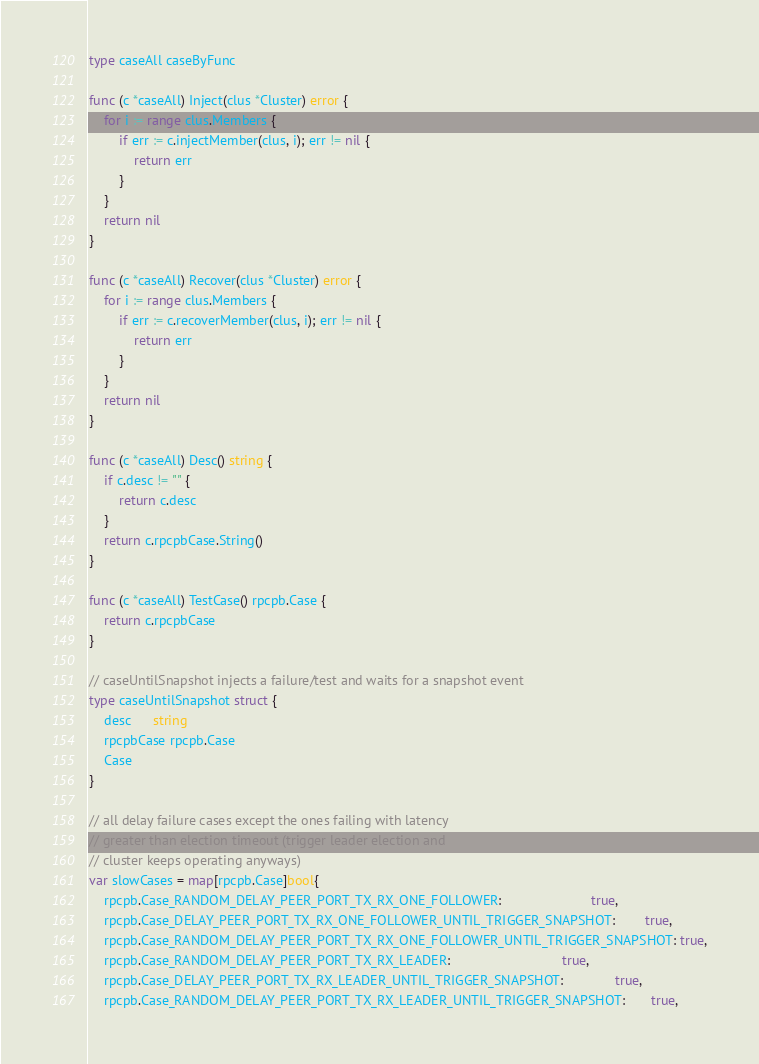<code> <loc_0><loc_0><loc_500><loc_500><_Go_>type caseAll caseByFunc

func (c *caseAll) Inject(clus *Cluster) error {
	for i := range clus.Members {
		if err := c.injectMember(clus, i); err != nil {
			return err
		}
	}
	return nil
}

func (c *caseAll) Recover(clus *Cluster) error {
	for i := range clus.Members {
		if err := c.recoverMember(clus, i); err != nil {
			return err
		}
	}
	return nil
}

func (c *caseAll) Desc() string {
	if c.desc != "" {
		return c.desc
	}
	return c.rpcpbCase.String()
}

func (c *caseAll) TestCase() rpcpb.Case {
	return c.rpcpbCase
}

// caseUntilSnapshot injects a failure/test and waits for a snapshot event
type caseUntilSnapshot struct {
	desc      string
	rpcpbCase rpcpb.Case
	Case
}

// all delay failure cases except the ones failing with latency
// greater than election timeout (trigger leader election and
// cluster keeps operating anyways)
var slowCases = map[rpcpb.Case]bool{
	rpcpb.Case_RANDOM_DELAY_PEER_PORT_TX_RX_ONE_FOLLOWER:                        true,
	rpcpb.Case_DELAY_PEER_PORT_TX_RX_ONE_FOLLOWER_UNTIL_TRIGGER_SNAPSHOT:        true,
	rpcpb.Case_RANDOM_DELAY_PEER_PORT_TX_RX_ONE_FOLLOWER_UNTIL_TRIGGER_SNAPSHOT: true,
	rpcpb.Case_RANDOM_DELAY_PEER_PORT_TX_RX_LEADER:                              true,
	rpcpb.Case_DELAY_PEER_PORT_TX_RX_LEADER_UNTIL_TRIGGER_SNAPSHOT:              true,
	rpcpb.Case_RANDOM_DELAY_PEER_PORT_TX_RX_LEADER_UNTIL_TRIGGER_SNAPSHOT:       true,</code> 